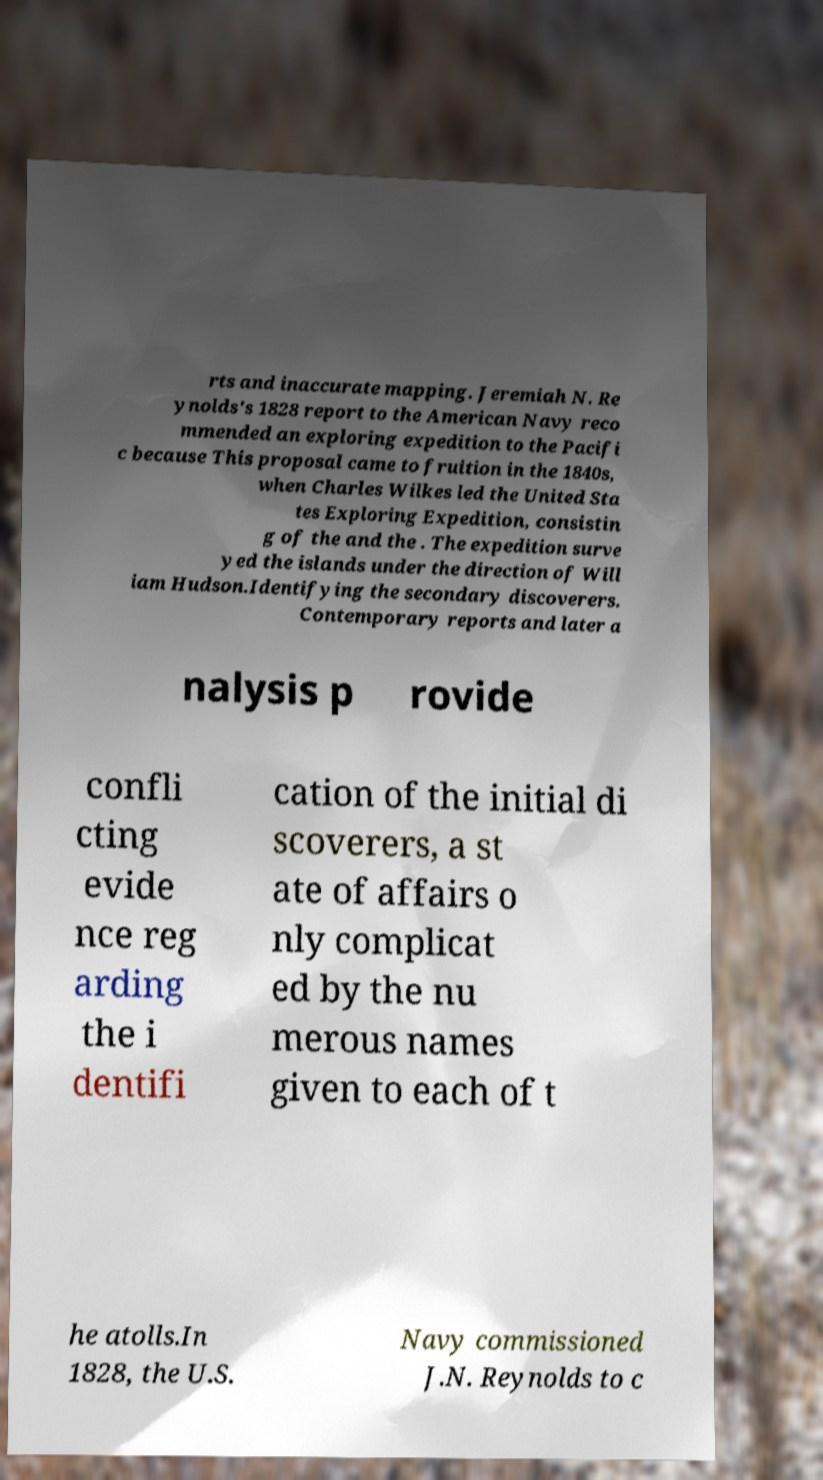What messages or text are displayed in this image? I need them in a readable, typed format. rts and inaccurate mapping. Jeremiah N. Re ynolds's 1828 report to the American Navy reco mmended an exploring expedition to the Pacifi c because This proposal came to fruition in the 1840s, when Charles Wilkes led the United Sta tes Exploring Expedition, consistin g of the and the . The expedition surve yed the islands under the direction of Will iam Hudson.Identifying the secondary discoverers. Contemporary reports and later a nalysis p rovide confli cting evide nce reg arding the i dentifi cation of the initial di scoverers, a st ate of affairs o nly complicat ed by the nu merous names given to each of t he atolls.In 1828, the U.S. Navy commissioned J.N. Reynolds to c 